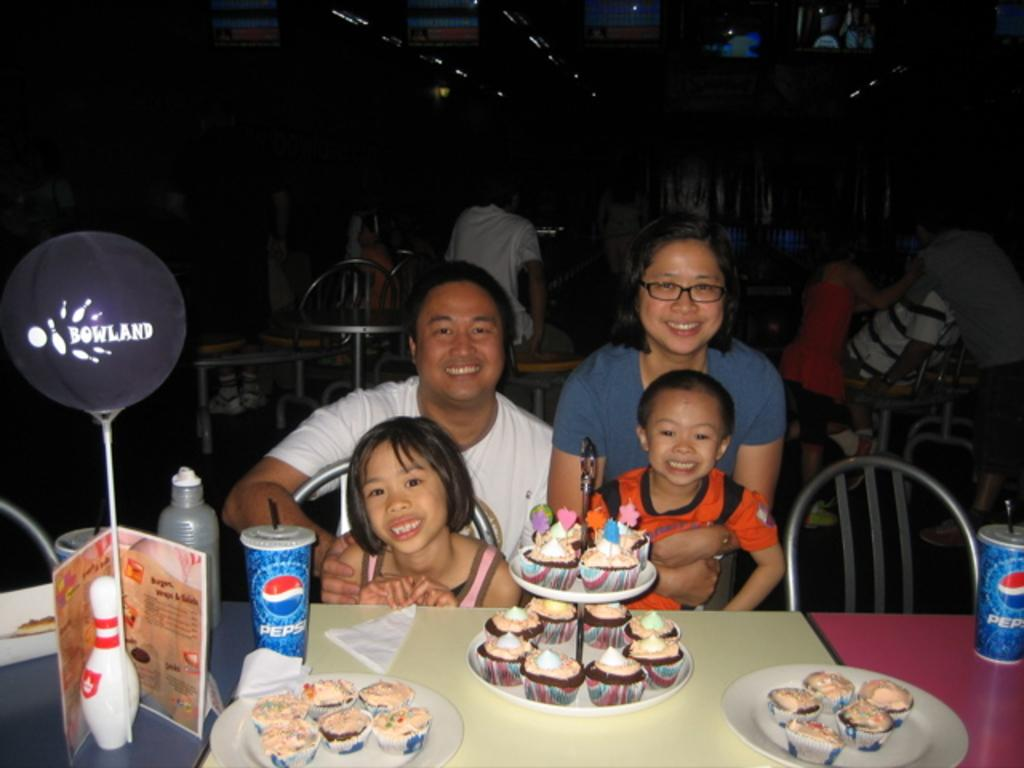How many people are in the image? There is a group of people in the image. What are the people doing in the image? The people are sitting on chairs. What objects can be seen on the table in the image? There is a plate, a balloon, a cake, and cookies on the table. What type of rhythm can be heard coming from the cake in the image? There is no rhythm associated with the cake in the image, as it is a dessert and not a musical instrument. 